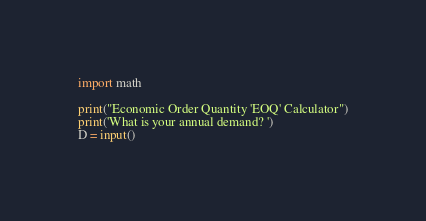Convert code to text. <code><loc_0><loc_0><loc_500><loc_500><_Python_>import math

print("Economic Order Quantity 'EOQ' Calculator")
print('What is your annual demand? ')
D = input()
</code> 